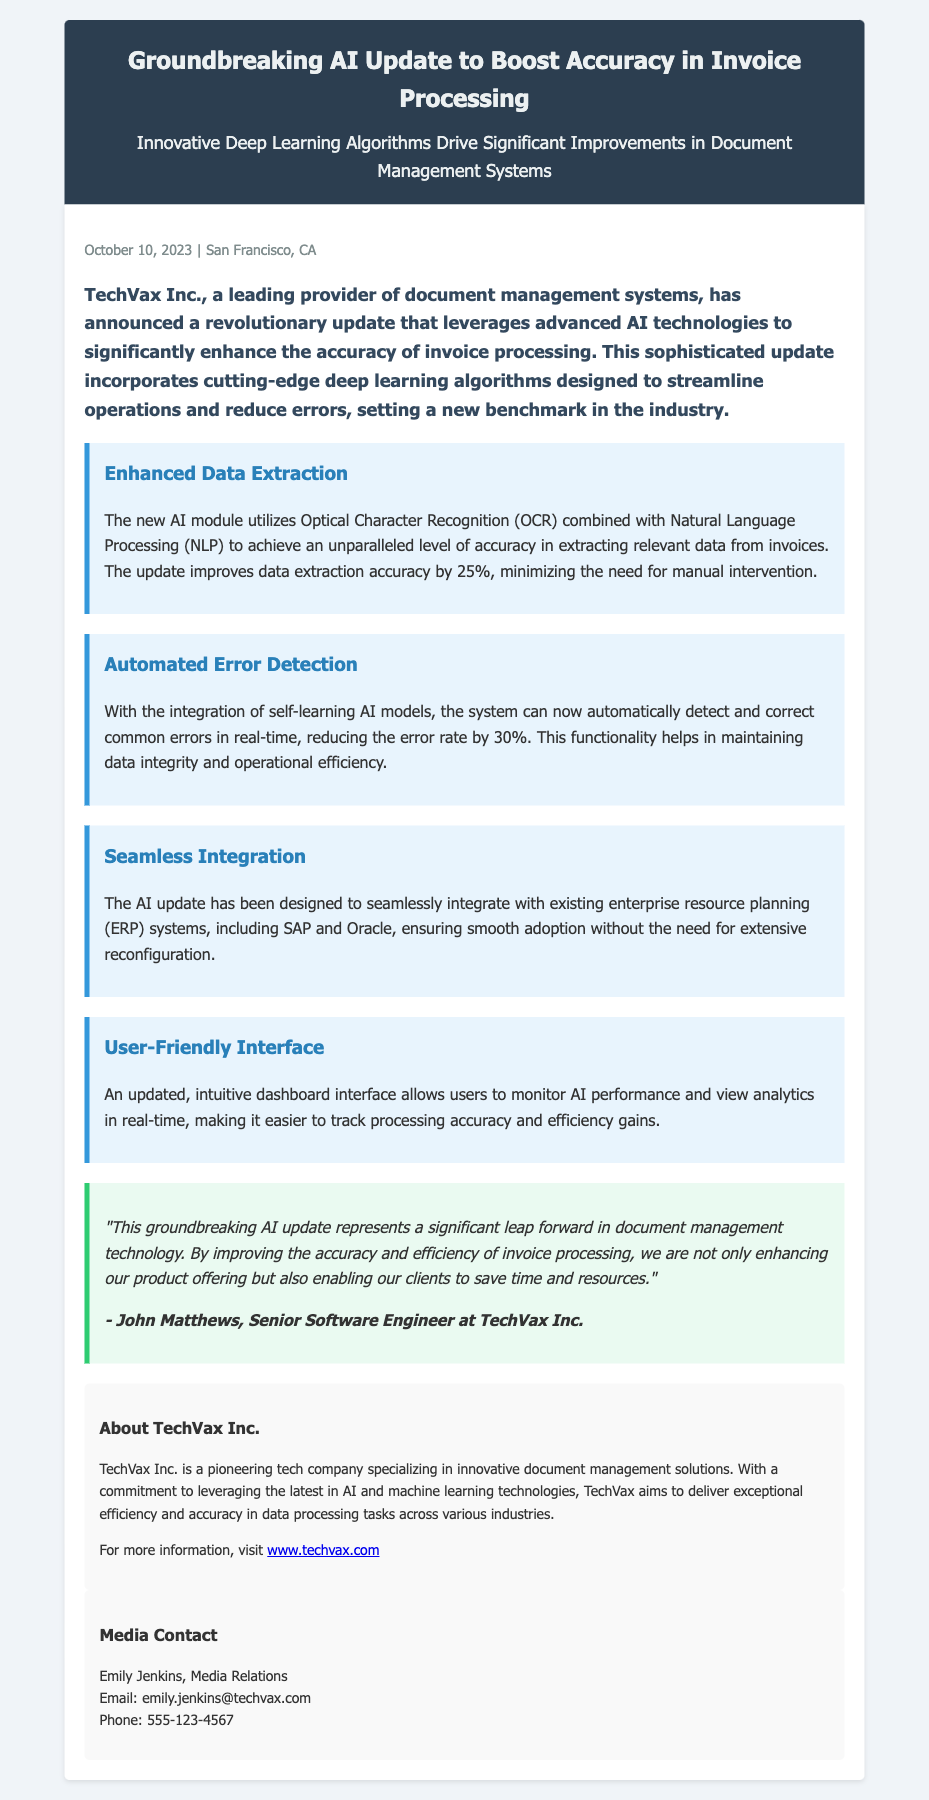What is the name of the company? The company mentioned in the press release is TechVax Inc.
Answer: TechVax Inc What date was the press release published? The press release was published on October 10, 2023.
Answer: October 10, 2023 What technology does the new AI module utilize for data extraction? The AI module utilizes Optical Character Recognition (OCR) and Natural Language Processing (NLP) for data extraction.
Answer: OCR and NLP By what percentage does the update improve data extraction accuracy? The update improves data extraction accuracy by 25%.
Answer: 25% What is the reduction in the error rate due to automated error detection? The automated error detection reduces the error rate by 30%.
Answer: 30% Who is the spokesperson quoted in the press release? The spokesperson quoted is John Matthews.
Answer: John Matthews What type of systems does the AI update seamlessly integrate with? The AI update integrates with enterprise resource planning (ERP) systems.
Answer: ERP systems What is the aim of TechVax Inc. as stated in the press release? TechVax Inc. aims to deliver exceptional efficiency and accuracy in data processing tasks.
Answer: Efficiency and accuracy What function does the updated dashboard interface provide? The updated dashboard interface allows users to monitor AI performance and view analytics in real-time.
Answer: Monitor AI performance and view analytics 